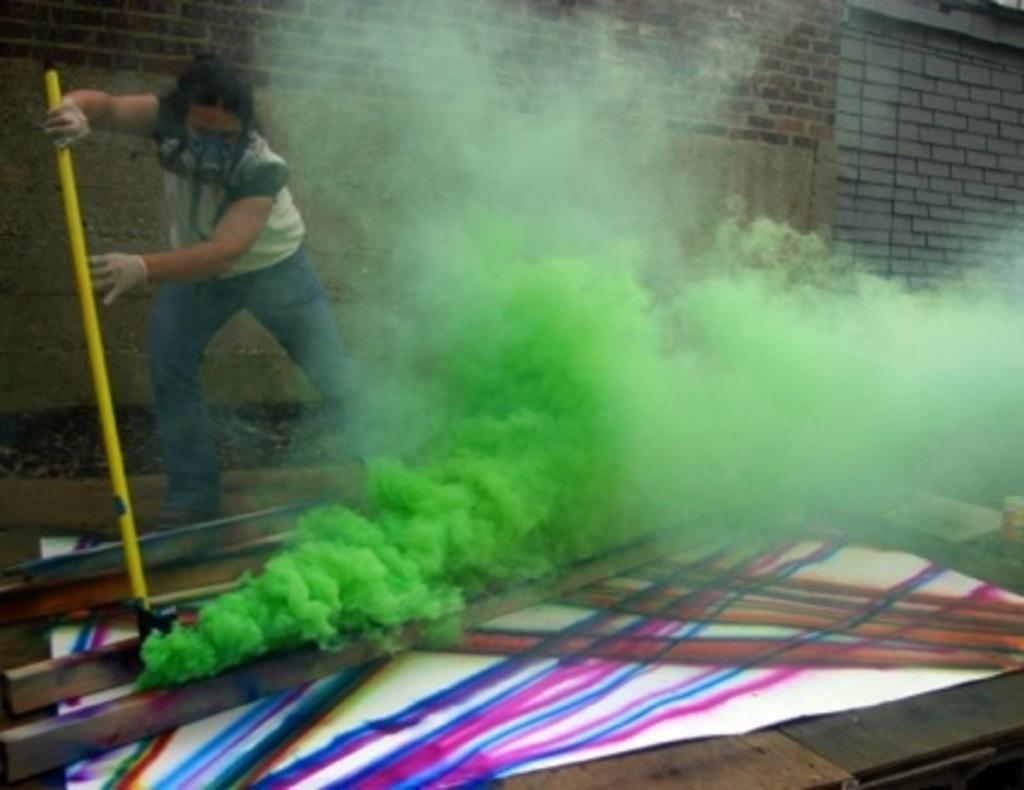What can be seen in the image? There is a person in the image. What is the person holding? The person is holding something, but the facts do not specify what it is. What is the color of the smoke in the image? The smoke in the image is green. What type of structure is visible in the image? There is a brick wall in the image. What is on the floor in the image? There is a colorful mat on the floor in the image. What type of quilt is being used to stop the car in the image? There is no car or quilt present in the image. How many stamps are visible on the person's hand in the image? There is no mention of stamps or the person's hand in the image. 